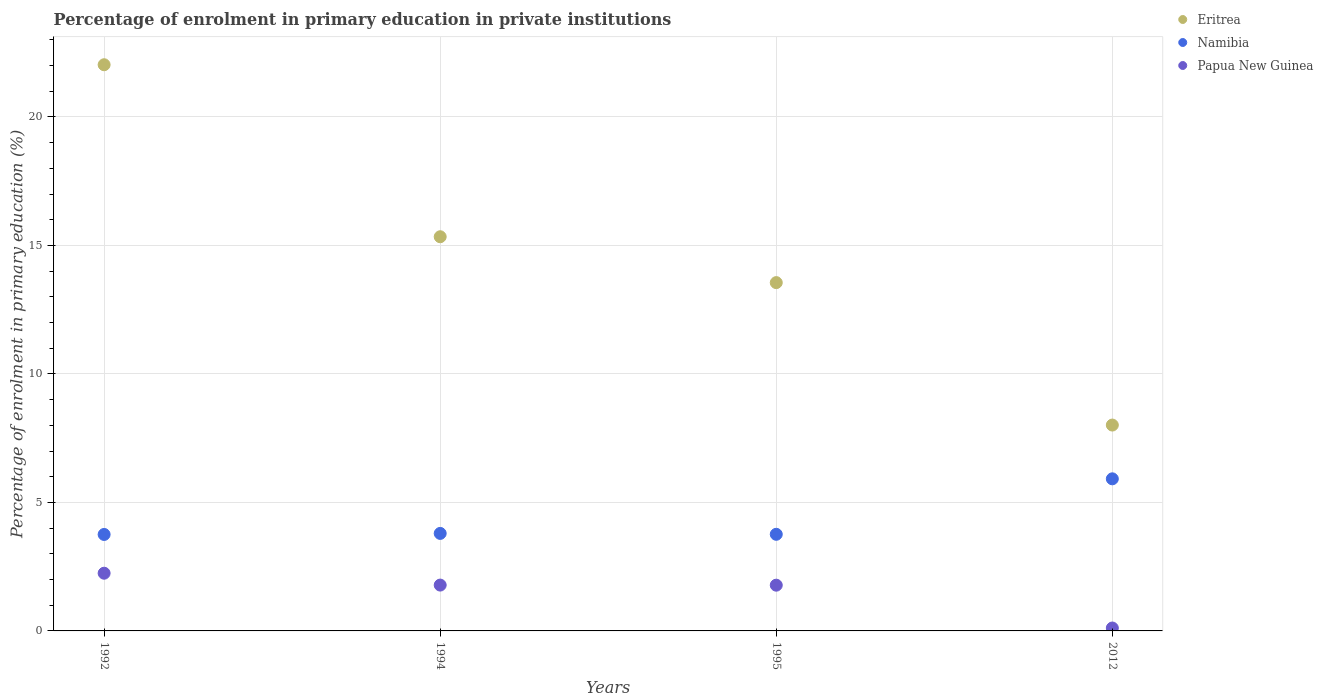What is the percentage of enrolment in primary education in Namibia in 1995?
Offer a very short reply. 3.76. Across all years, what is the maximum percentage of enrolment in primary education in Namibia?
Offer a very short reply. 5.92. Across all years, what is the minimum percentage of enrolment in primary education in Namibia?
Make the answer very short. 3.75. What is the total percentage of enrolment in primary education in Namibia in the graph?
Your answer should be compact. 17.23. What is the difference between the percentage of enrolment in primary education in Eritrea in 1992 and that in 1995?
Your response must be concise. 8.48. What is the difference between the percentage of enrolment in primary education in Eritrea in 1995 and the percentage of enrolment in primary education in Papua New Guinea in 2012?
Your response must be concise. 13.44. What is the average percentage of enrolment in primary education in Papua New Guinea per year?
Your answer should be compact. 1.48. In the year 1992, what is the difference between the percentage of enrolment in primary education in Namibia and percentage of enrolment in primary education in Eritrea?
Your response must be concise. -18.28. What is the ratio of the percentage of enrolment in primary education in Papua New Guinea in 1992 to that in 2012?
Your answer should be very brief. 19.8. Is the percentage of enrolment in primary education in Namibia in 1992 less than that in 1995?
Make the answer very short. Yes. Is the difference between the percentage of enrolment in primary education in Namibia in 1992 and 1995 greater than the difference between the percentage of enrolment in primary education in Eritrea in 1992 and 1995?
Give a very brief answer. No. What is the difference between the highest and the second highest percentage of enrolment in primary education in Papua New Guinea?
Your response must be concise. 0.46. What is the difference between the highest and the lowest percentage of enrolment in primary education in Papua New Guinea?
Give a very brief answer. 2.13. In how many years, is the percentage of enrolment in primary education in Namibia greater than the average percentage of enrolment in primary education in Namibia taken over all years?
Offer a terse response. 1. How many dotlines are there?
Your response must be concise. 3. What is the difference between two consecutive major ticks on the Y-axis?
Ensure brevity in your answer.  5. Does the graph contain any zero values?
Your response must be concise. No. Where does the legend appear in the graph?
Provide a succinct answer. Top right. How many legend labels are there?
Your answer should be very brief. 3. What is the title of the graph?
Your response must be concise. Percentage of enrolment in primary education in private institutions. What is the label or title of the X-axis?
Keep it short and to the point. Years. What is the label or title of the Y-axis?
Make the answer very short. Percentage of enrolment in primary education (%). What is the Percentage of enrolment in primary education (%) of Eritrea in 1992?
Ensure brevity in your answer.  22.03. What is the Percentage of enrolment in primary education (%) in Namibia in 1992?
Your answer should be compact. 3.75. What is the Percentage of enrolment in primary education (%) of Papua New Guinea in 1992?
Your answer should be compact. 2.25. What is the Percentage of enrolment in primary education (%) in Eritrea in 1994?
Provide a short and direct response. 15.34. What is the Percentage of enrolment in primary education (%) of Namibia in 1994?
Your answer should be very brief. 3.79. What is the Percentage of enrolment in primary education (%) of Papua New Guinea in 1994?
Your answer should be compact. 1.78. What is the Percentage of enrolment in primary education (%) of Eritrea in 1995?
Provide a succinct answer. 13.55. What is the Percentage of enrolment in primary education (%) in Namibia in 1995?
Give a very brief answer. 3.76. What is the Percentage of enrolment in primary education (%) in Papua New Guinea in 1995?
Your answer should be compact. 1.78. What is the Percentage of enrolment in primary education (%) of Eritrea in 2012?
Provide a short and direct response. 8.01. What is the Percentage of enrolment in primary education (%) in Namibia in 2012?
Offer a very short reply. 5.92. What is the Percentage of enrolment in primary education (%) of Papua New Guinea in 2012?
Keep it short and to the point. 0.11. Across all years, what is the maximum Percentage of enrolment in primary education (%) of Eritrea?
Keep it short and to the point. 22.03. Across all years, what is the maximum Percentage of enrolment in primary education (%) of Namibia?
Your answer should be very brief. 5.92. Across all years, what is the maximum Percentage of enrolment in primary education (%) in Papua New Guinea?
Provide a succinct answer. 2.25. Across all years, what is the minimum Percentage of enrolment in primary education (%) in Eritrea?
Offer a terse response. 8.01. Across all years, what is the minimum Percentage of enrolment in primary education (%) of Namibia?
Ensure brevity in your answer.  3.75. Across all years, what is the minimum Percentage of enrolment in primary education (%) in Papua New Guinea?
Offer a very short reply. 0.11. What is the total Percentage of enrolment in primary education (%) in Eritrea in the graph?
Offer a terse response. 58.93. What is the total Percentage of enrolment in primary education (%) in Namibia in the graph?
Offer a terse response. 17.23. What is the total Percentage of enrolment in primary education (%) in Papua New Guinea in the graph?
Provide a succinct answer. 5.92. What is the difference between the Percentage of enrolment in primary education (%) of Eritrea in 1992 and that in 1994?
Provide a succinct answer. 6.69. What is the difference between the Percentage of enrolment in primary education (%) in Namibia in 1992 and that in 1994?
Your response must be concise. -0.04. What is the difference between the Percentage of enrolment in primary education (%) of Papua New Guinea in 1992 and that in 1994?
Your answer should be very brief. 0.46. What is the difference between the Percentage of enrolment in primary education (%) of Eritrea in 1992 and that in 1995?
Offer a very short reply. 8.48. What is the difference between the Percentage of enrolment in primary education (%) of Namibia in 1992 and that in 1995?
Make the answer very short. -0.01. What is the difference between the Percentage of enrolment in primary education (%) of Papua New Guinea in 1992 and that in 1995?
Offer a terse response. 0.47. What is the difference between the Percentage of enrolment in primary education (%) in Eritrea in 1992 and that in 2012?
Ensure brevity in your answer.  14.02. What is the difference between the Percentage of enrolment in primary education (%) in Namibia in 1992 and that in 2012?
Your answer should be very brief. -2.16. What is the difference between the Percentage of enrolment in primary education (%) in Papua New Guinea in 1992 and that in 2012?
Your answer should be compact. 2.13. What is the difference between the Percentage of enrolment in primary education (%) of Eritrea in 1994 and that in 1995?
Make the answer very short. 1.79. What is the difference between the Percentage of enrolment in primary education (%) in Namibia in 1994 and that in 1995?
Your answer should be very brief. 0.03. What is the difference between the Percentage of enrolment in primary education (%) in Papua New Guinea in 1994 and that in 1995?
Provide a short and direct response. 0. What is the difference between the Percentage of enrolment in primary education (%) of Eritrea in 1994 and that in 2012?
Your response must be concise. 7.33. What is the difference between the Percentage of enrolment in primary education (%) of Namibia in 1994 and that in 2012?
Keep it short and to the point. -2.12. What is the difference between the Percentage of enrolment in primary education (%) of Papua New Guinea in 1994 and that in 2012?
Your answer should be compact. 1.67. What is the difference between the Percentage of enrolment in primary education (%) of Eritrea in 1995 and that in 2012?
Your answer should be compact. 5.54. What is the difference between the Percentage of enrolment in primary education (%) in Namibia in 1995 and that in 2012?
Offer a terse response. -2.16. What is the difference between the Percentage of enrolment in primary education (%) in Papua New Guinea in 1995 and that in 2012?
Your answer should be very brief. 1.67. What is the difference between the Percentage of enrolment in primary education (%) of Eritrea in 1992 and the Percentage of enrolment in primary education (%) of Namibia in 1994?
Offer a terse response. 18.24. What is the difference between the Percentage of enrolment in primary education (%) of Eritrea in 1992 and the Percentage of enrolment in primary education (%) of Papua New Guinea in 1994?
Offer a very short reply. 20.25. What is the difference between the Percentage of enrolment in primary education (%) in Namibia in 1992 and the Percentage of enrolment in primary education (%) in Papua New Guinea in 1994?
Ensure brevity in your answer.  1.97. What is the difference between the Percentage of enrolment in primary education (%) in Eritrea in 1992 and the Percentage of enrolment in primary education (%) in Namibia in 1995?
Offer a terse response. 18.27. What is the difference between the Percentage of enrolment in primary education (%) in Eritrea in 1992 and the Percentage of enrolment in primary education (%) in Papua New Guinea in 1995?
Your answer should be very brief. 20.25. What is the difference between the Percentage of enrolment in primary education (%) of Namibia in 1992 and the Percentage of enrolment in primary education (%) of Papua New Guinea in 1995?
Provide a succinct answer. 1.97. What is the difference between the Percentage of enrolment in primary education (%) in Eritrea in 1992 and the Percentage of enrolment in primary education (%) in Namibia in 2012?
Your answer should be very brief. 16.11. What is the difference between the Percentage of enrolment in primary education (%) of Eritrea in 1992 and the Percentage of enrolment in primary education (%) of Papua New Guinea in 2012?
Offer a very short reply. 21.92. What is the difference between the Percentage of enrolment in primary education (%) of Namibia in 1992 and the Percentage of enrolment in primary education (%) of Papua New Guinea in 2012?
Give a very brief answer. 3.64. What is the difference between the Percentage of enrolment in primary education (%) of Eritrea in 1994 and the Percentage of enrolment in primary education (%) of Namibia in 1995?
Your answer should be compact. 11.58. What is the difference between the Percentage of enrolment in primary education (%) in Eritrea in 1994 and the Percentage of enrolment in primary education (%) in Papua New Guinea in 1995?
Keep it short and to the point. 13.56. What is the difference between the Percentage of enrolment in primary education (%) of Namibia in 1994 and the Percentage of enrolment in primary education (%) of Papua New Guinea in 1995?
Your answer should be very brief. 2.01. What is the difference between the Percentage of enrolment in primary education (%) of Eritrea in 1994 and the Percentage of enrolment in primary education (%) of Namibia in 2012?
Provide a succinct answer. 9.42. What is the difference between the Percentage of enrolment in primary education (%) of Eritrea in 1994 and the Percentage of enrolment in primary education (%) of Papua New Guinea in 2012?
Your answer should be compact. 15.23. What is the difference between the Percentage of enrolment in primary education (%) in Namibia in 1994 and the Percentage of enrolment in primary education (%) in Papua New Guinea in 2012?
Provide a succinct answer. 3.68. What is the difference between the Percentage of enrolment in primary education (%) in Eritrea in 1995 and the Percentage of enrolment in primary education (%) in Namibia in 2012?
Make the answer very short. 7.63. What is the difference between the Percentage of enrolment in primary education (%) in Eritrea in 1995 and the Percentage of enrolment in primary education (%) in Papua New Guinea in 2012?
Keep it short and to the point. 13.44. What is the difference between the Percentage of enrolment in primary education (%) in Namibia in 1995 and the Percentage of enrolment in primary education (%) in Papua New Guinea in 2012?
Give a very brief answer. 3.65. What is the average Percentage of enrolment in primary education (%) in Eritrea per year?
Offer a terse response. 14.73. What is the average Percentage of enrolment in primary education (%) in Namibia per year?
Your answer should be very brief. 4.31. What is the average Percentage of enrolment in primary education (%) in Papua New Guinea per year?
Your answer should be very brief. 1.48. In the year 1992, what is the difference between the Percentage of enrolment in primary education (%) in Eritrea and Percentage of enrolment in primary education (%) in Namibia?
Provide a succinct answer. 18.28. In the year 1992, what is the difference between the Percentage of enrolment in primary education (%) in Eritrea and Percentage of enrolment in primary education (%) in Papua New Guinea?
Ensure brevity in your answer.  19.79. In the year 1992, what is the difference between the Percentage of enrolment in primary education (%) in Namibia and Percentage of enrolment in primary education (%) in Papua New Guinea?
Offer a very short reply. 1.51. In the year 1994, what is the difference between the Percentage of enrolment in primary education (%) in Eritrea and Percentage of enrolment in primary education (%) in Namibia?
Provide a short and direct response. 11.54. In the year 1994, what is the difference between the Percentage of enrolment in primary education (%) in Eritrea and Percentage of enrolment in primary education (%) in Papua New Guinea?
Ensure brevity in your answer.  13.55. In the year 1994, what is the difference between the Percentage of enrolment in primary education (%) in Namibia and Percentage of enrolment in primary education (%) in Papua New Guinea?
Provide a succinct answer. 2.01. In the year 1995, what is the difference between the Percentage of enrolment in primary education (%) of Eritrea and Percentage of enrolment in primary education (%) of Namibia?
Your response must be concise. 9.79. In the year 1995, what is the difference between the Percentage of enrolment in primary education (%) of Eritrea and Percentage of enrolment in primary education (%) of Papua New Guinea?
Offer a very short reply. 11.77. In the year 1995, what is the difference between the Percentage of enrolment in primary education (%) in Namibia and Percentage of enrolment in primary education (%) in Papua New Guinea?
Provide a succinct answer. 1.98. In the year 2012, what is the difference between the Percentage of enrolment in primary education (%) of Eritrea and Percentage of enrolment in primary education (%) of Namibia?
Make the answer very short. 2.09. In the year 2012, what is the difference between the Percentage of enrolment in primary education (%) in Eritrea and Percentage of enrolment in primary education (%) in Papua New Guinea?
Your answer should be very brief. 7.9. In the year 2012, what is the difference between the Percentage of enrolment in primary education (%) in Namibia and Percentage of enrolment in primary education (%) in Papua New Guinea?
Make the answer very short. 5.8. What is the ratio of the Percentage of enrolment in primary education (%) in Eritrea in 1992 to that in 1994?
Provide a short and direct response. 1.44. What is the ratio of the Percentage of enrolment in primary education (%) in Namibia in 1992 to that in 1994?
Your answer should be compact. 0.99. What is the ratio of the Percentage of enrolment in primary education (%) in Papua New Guinea in 1992 to that in 1994?
Keep it short and to the point. 1.26. What is the ratio of the Percentage of enrolment in primary education (%) of Eritrea in 1992 to that in 1995?
Provide a short and direct response. 1.63. What is the ratio of the Percentage of enrolment in primary education (%) of Papua New Guinea in 1992 to that in 1995?
Make the answer very short. 1.26. What is the ratio of the Percentage of enrolment in primary education (%) of Eritrea in 1992 to that in 2012?
Make the answer very short. 2.75. What is the ratio of the Percentage of enrolment in primary education (%) of Namibia in 1992 to that in 2012?
Provide a succinct answer. 0.63. What is the ratio of the Percentage of enrolment in primary education (%) of Papua New Guinea in 1992 to that in 2012?
Ensure brevity in your answer.  19.8. What is the ratio of the Percentage of enrolment in primary education (%) of Eritrea in 1994 to that in 1995?
Keep it short and to the point. 1.13. What is the ratio of the Percentage of enrolment in primary education (%) of Namibia in 1994 to that in 1995?
Your response must be concise. 1.01. What is the ratio of the Percentage of enrolment in primary education (%) of Eritrea in 1994 to that in 2012?
Ensure brevity in your answer.  1.91. What is the ratio of the Percentage of enrolment in primary education (%) in Namibia in 1994 to that in 2012?
Your answer should be compact. 0.64. What is the ratio of the Percentage of enrolment in primary education (%) in Papua New Guinea in 1994 to that in 2012?
Offer a very short reply. 15.73. What is the ratio of the Percentage of enrolment in primary education (%) in Eritrea in 1995 to that in 2012?
Your response must be concise. 1.69. What is the ratio of the Percentage of enrolment in primary education (%) of Namibia in 1995 to that in 2012?
Make the answer very short. 0.64. What is the ratio of the Percentage of enrolment in primary education (%) of Papua New Guinea in 1995 to that in 2012?
Give a very brief answer. 15.7. What is the difference between the highest and the second highest Percentage of enrolment in primary education (%) of Eritrea?
Make the answer very short. 6.69. What is the difference between the highest and the second highest Percentage of enrolment in primary education (%) of Namibia?
Your answer should be compact. 2.12. What is the difference between the highest and the second highest Percentage of enrolment in primary education (%) in Papua New Guinea?
Your answer should be compact. 0.46. What is the difference between the highest and the lowest Percentage of enrolment in primary education (%) in Eritrea?
Keep it short and to the point. 14.02. What is the difference between the highest and the lowest Percentage of enrolment in primary education (%) in Namibia?
Your answer should be compact. 2.16. What is the difference between the highest and the lowest Percentage of enrolment in primary education (%) of Papua New Guinea?
Keep it short and to the point. 2.13. 